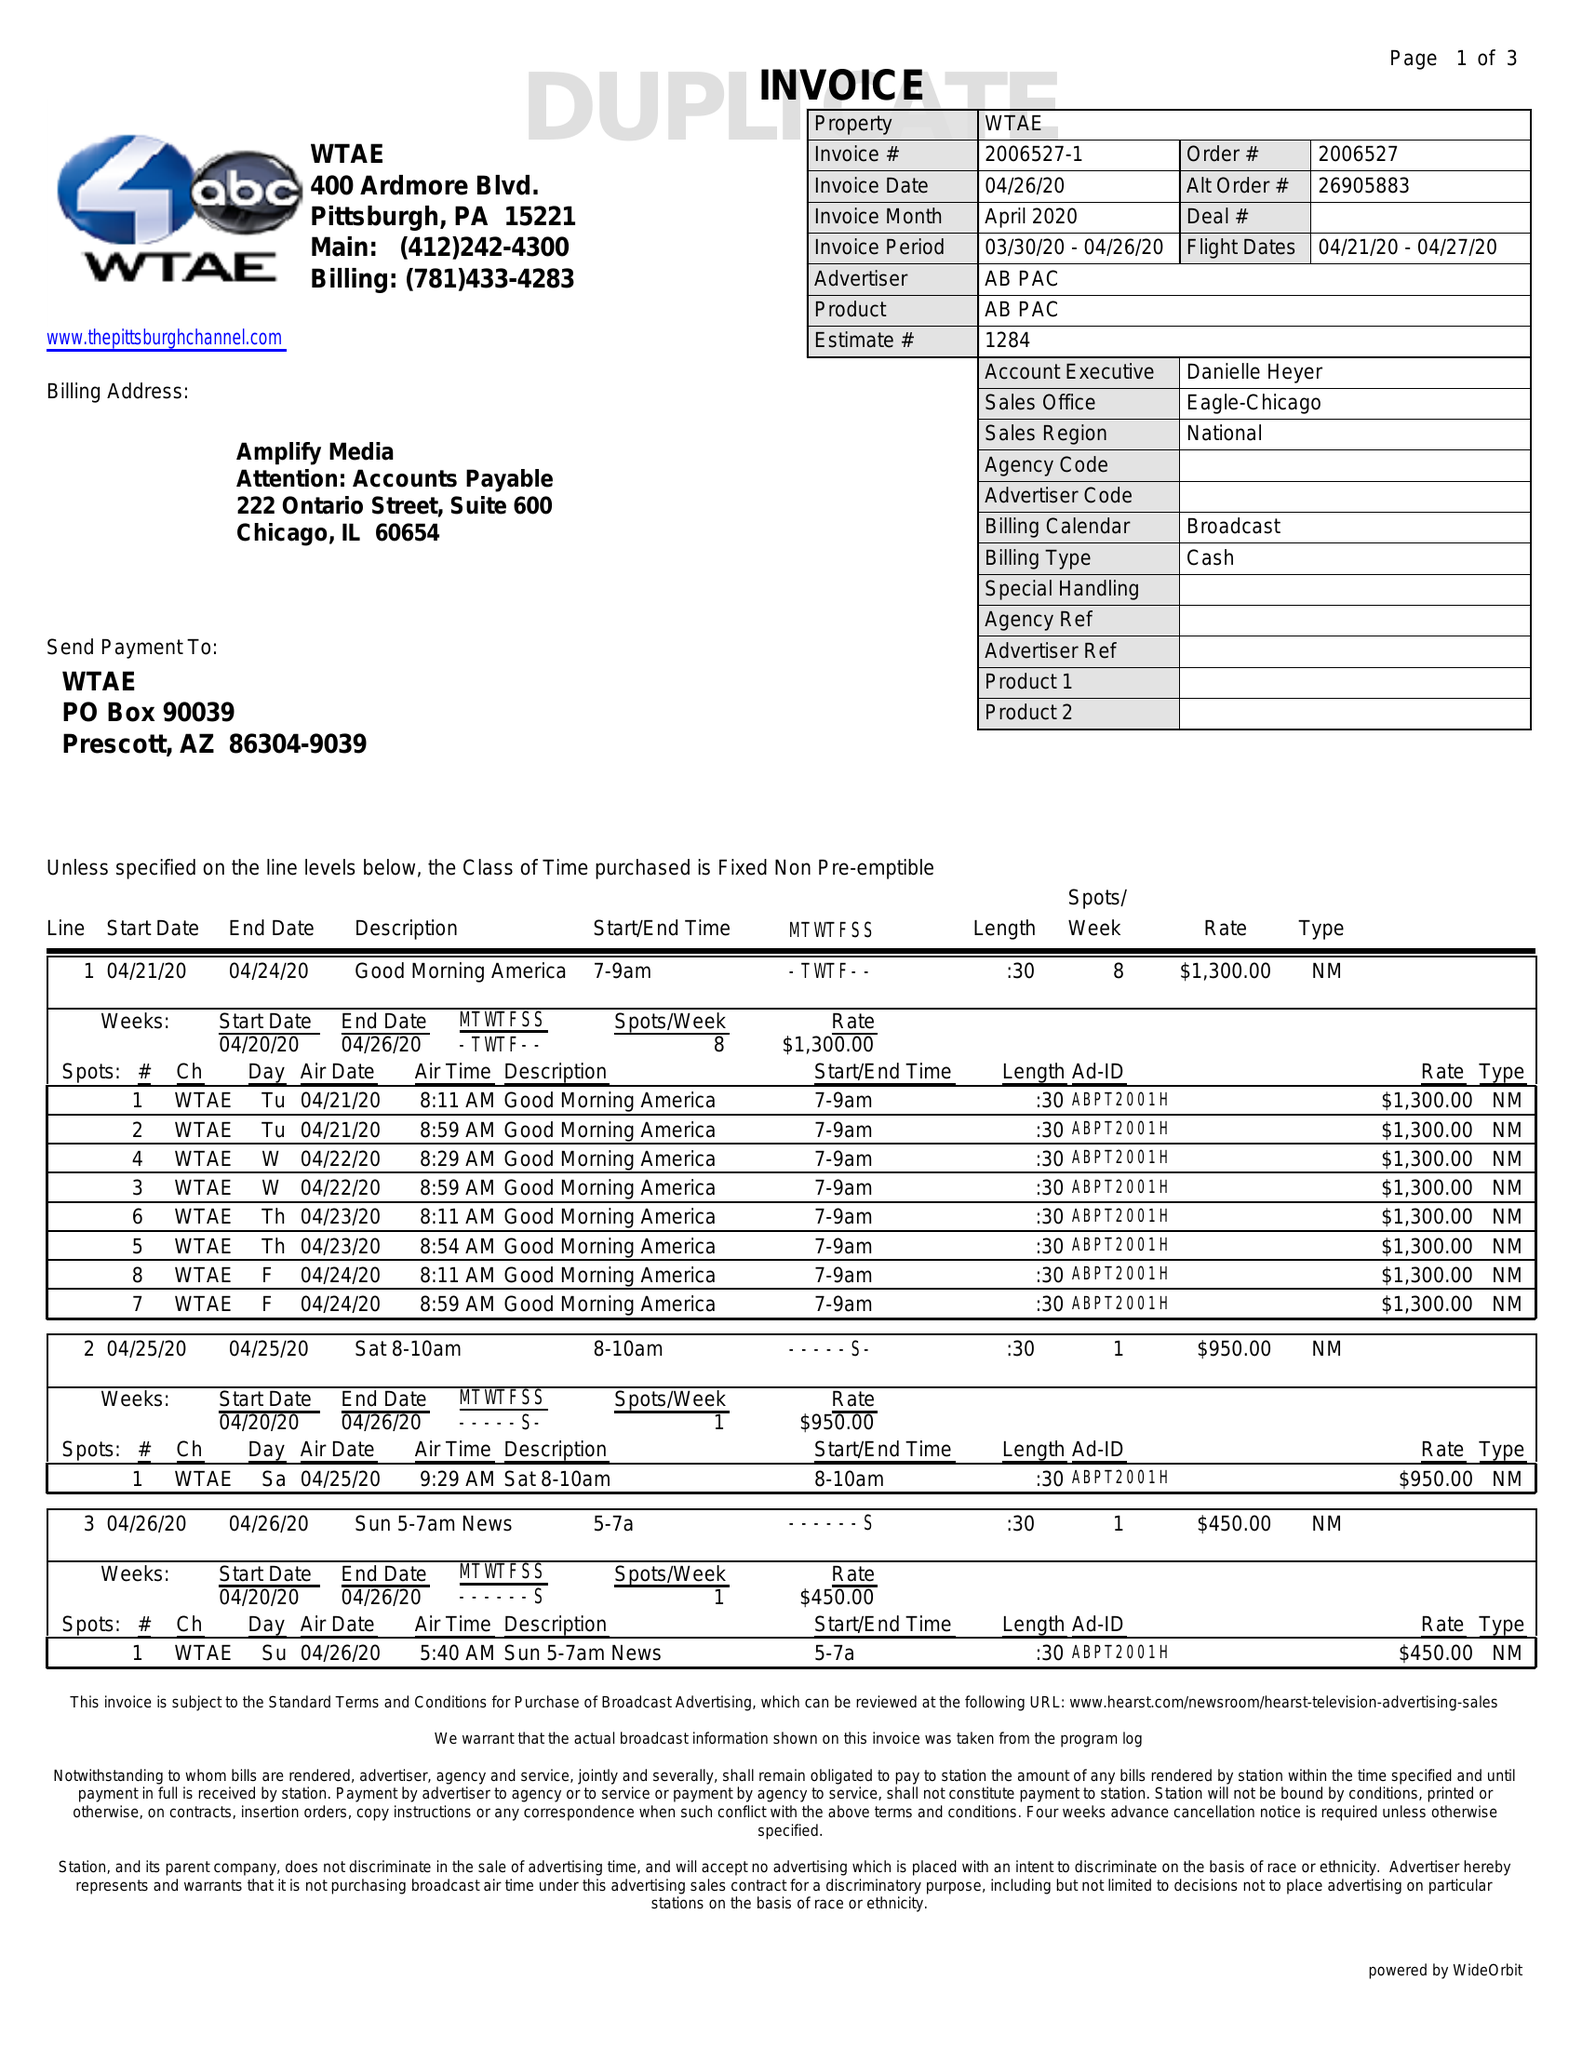What is the value for the contract_num?
Answer the question using a single word or phrase. 2006527 